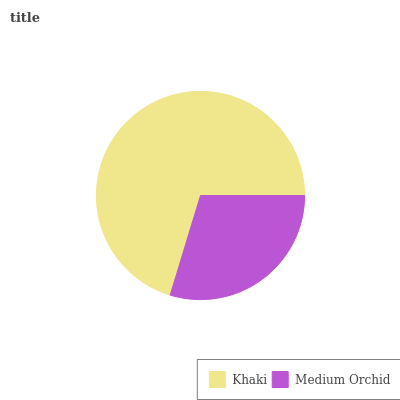Is Medium Orchid the minimum?
Answer yes or no. Yes. Is Khaki the maximum?
Answer yes or no. Yes. Is Medium Orchid the maximum?
Answer yes or no. No. Is Khaki greater than Medium Orchid?
Answer yes or no. Yes. Is Medium Orchid less than Khaki?
Answer yes or no. Yes. Is Medium Orchid greater than Khaki?
Answer yes or no. No. Is Khaki less than Medium Orchid?
Answer yes or no. No. Is Khaki the high median?
Answer yes or no. Yes. Is Medium Orchid the low median?
Answer yes or no. Yes. Is Medium Orchid the high median?
Answer yes or no. No. Is Khaki the low median?
Answer yes or no. No. 